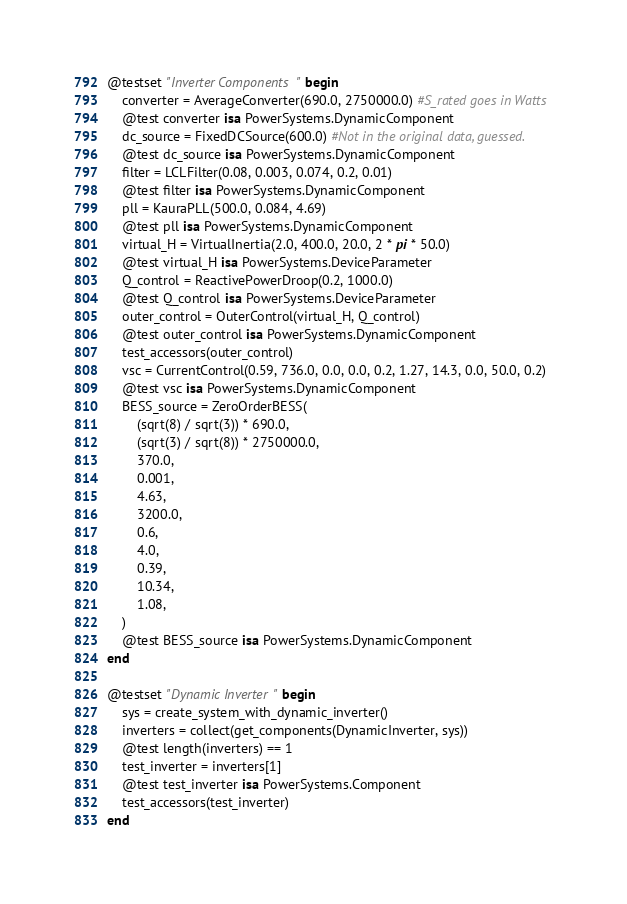Convert code to text. <code><loc_0><loc_0><loc_500><loc_500><_Julia_>@testset "Inverter Components" begin
    converter = AverageConverter(690.0, 2750000.0) #S_rated goes in Watts
    @test converter isa PowerSystems.DynamicComponent
    dc_source = FixedDCSource(600.0) #Not in the original data, guessed.
    @test dc_source isa PowerSystems.DynamicComponent
    filter = LCLFilter(0.08, 0.003, 0.074, 0.2, 0.01)
    @test filter isa PowerSystems.DynamicComponent
    pll = KauraPLL(500.0, 0.084, 4.69)
    @test pll isa PowerSystems.DynamicComponent
    virtual_H = VirtualInertia(2.0, 400.0, 20.0, 2 * pi * 50.0)
    @test virtual_H isa PowerSystems.DeviceParameter
    Q_control = ReactivePowerDroop(0.2, 1000.0)
    @test Q_control isa PowerSystems.DeviceParameter
    outer_control = OuterControl(virtual_H, Q_control)
    @test outer_control isa PowerSystems.DynamicComponent
    test_accessors(outer_control)
    vsc = CurrentControl(0.59, 736.0, 0.0, 0.0, 0.2, 1.27, 14.3, 0.0, 50.0, 0.2)
    @test vsc isa PowerSystems.DynamicComponent
    BESS_source = ZeroOrderBESS(
        (sqrt(8) / sqrt(3)) * 690.0,
        (sqrt(3) / sqrt(8)) * 2750000.0,
        370.0,
        0.001,
        4.63,
        3200.0,
        0.6,
        4.0,
        0.39,
        10.34,
        1.08,
    )
    @test BESS_source isa PowerSystems.DynamicComponent
end

@testset "Dynamic Inverter" begin
    sys = create_system_with_dynamic_inverter()
    inverters = collect(get_components(DynamicInverter, sys))
    @test length(inverters) == 1
    test_inverter = inverters[1]
    @test test_inverter isa PowerSystems.Component
    test_accessors(test_inverter)
end
</code> 